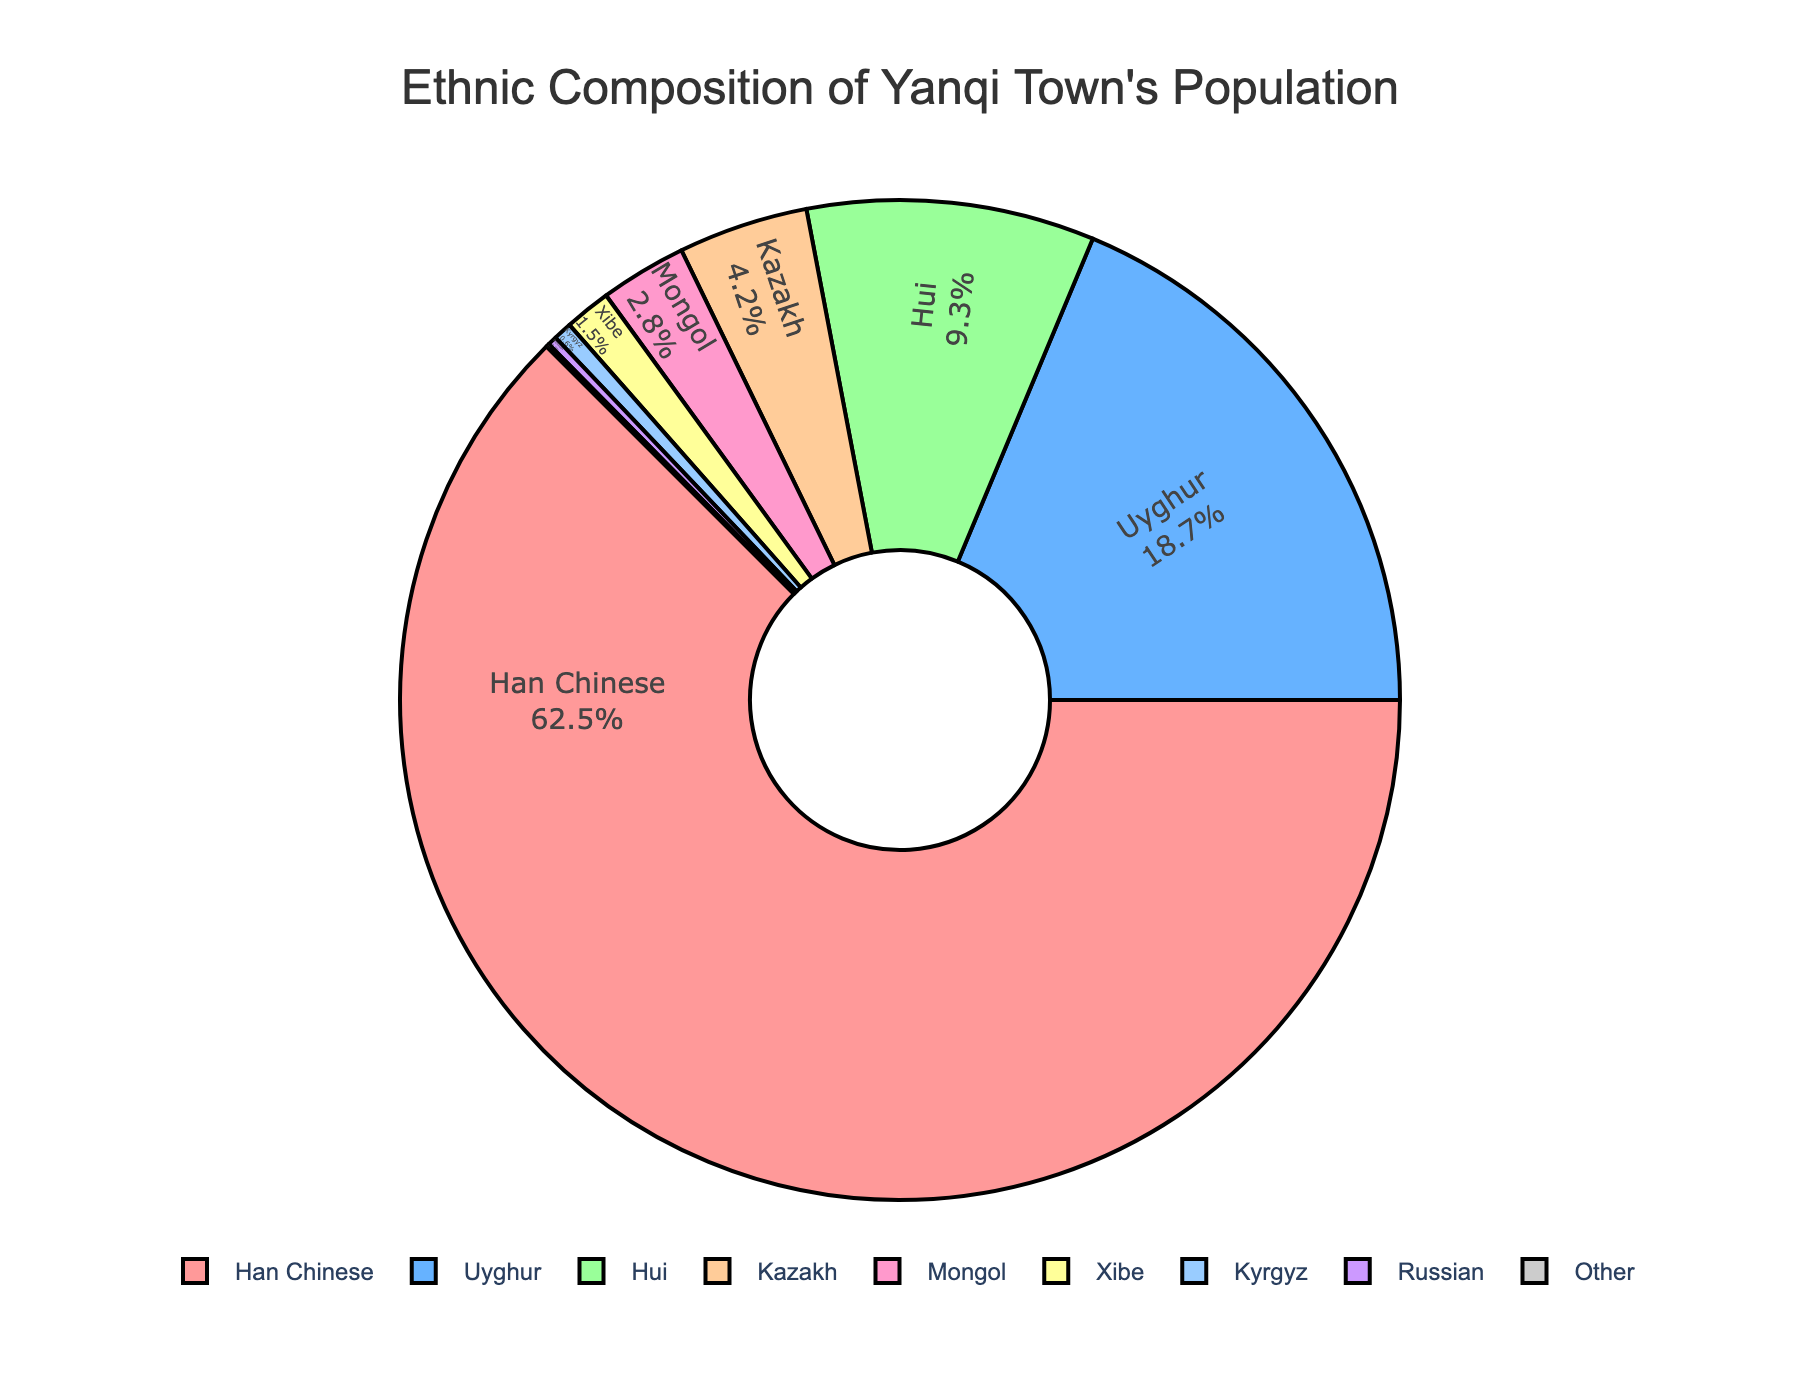What percentage of the population in Yanqi Town is composed of Han Chinese and Hui people combined? To determine the combined percentage, we add the percentages of Han Chinese (62.5%) and Hui (9.3%). Therefore, 62.5 + 9.3 = 71.8%.
Answer: 71.8% How much larger is the population percentage of Han Chinese compared to Uyghurs in Yanqi Town? To find the difference, subtract the percentage of Uyghurs (18.7%) from Han Chinese (62.5%). Thus, 62.5 - 18.7 = 43.8%.
Answer: 43.8% Which ethnicity has a slightly higher population percentage: Kazakh or Mongol? The pie chart shows Kazakh at 4.2% and Mongol at 2.8%. Since 4.2% is greater than 2.8%, Kazakh has a higher population percentage.
Answer: Kazakh If you were to combine all the ethnicities other than Han Chinese, would their population percentage be greater than that of the Han Chinese? First, sum the percentages of all other ethnicities: 18.7 + 9.3 + 4.2 + 2.8 + 1.5 + 0.6 + 0.3 + 0.1 = 37.5%. Compare this to the Han Chinese percentage (62.5%). Since 37.5% is less than 62.5%, the combined population percentage of other ethnicities is not greater.
Answer: No Which ethnic groups have less than 1% of the total population of Yanqi Town? The pie chart shows that Xibe (1.5%), Kyrgyz (0.6%), Russian (0.3%), and Other (0.1%) are the groups with population percentages below 1%.
Answer: Kyrgyz, Russian, Other What is the color used to represent the Uyghur population on the pie chart? In the pie chart, each section representing an ethnicity is color-coded. The Uyghur population is represented by a light blue section.
Answer: Light blue If you combine the percentages of Kazakh and Xibe, do they exceed the percentage of Hui people? First, add the percentages of Kazakh (4.2%) and Xibe (1.5%): 4.2 + 1.5 = 5.7%. Compare this to the Hui percentage (9.3%). Since 5.7% is less than 9.3%, their combined percentage does not exceed that of Hui people.
Answer: No What is the combined percentage of Mongol, Kyrgyz, Russian, and Other ethnic populations? Add the percentages of Mongol (2.8%), Kyrgyz (0.6%), Russian (0.3%), and Other (0.1%): 2.8 + 0.6 + 0.3 + 0.1 = 3.8%.
Answer: 3.8% 